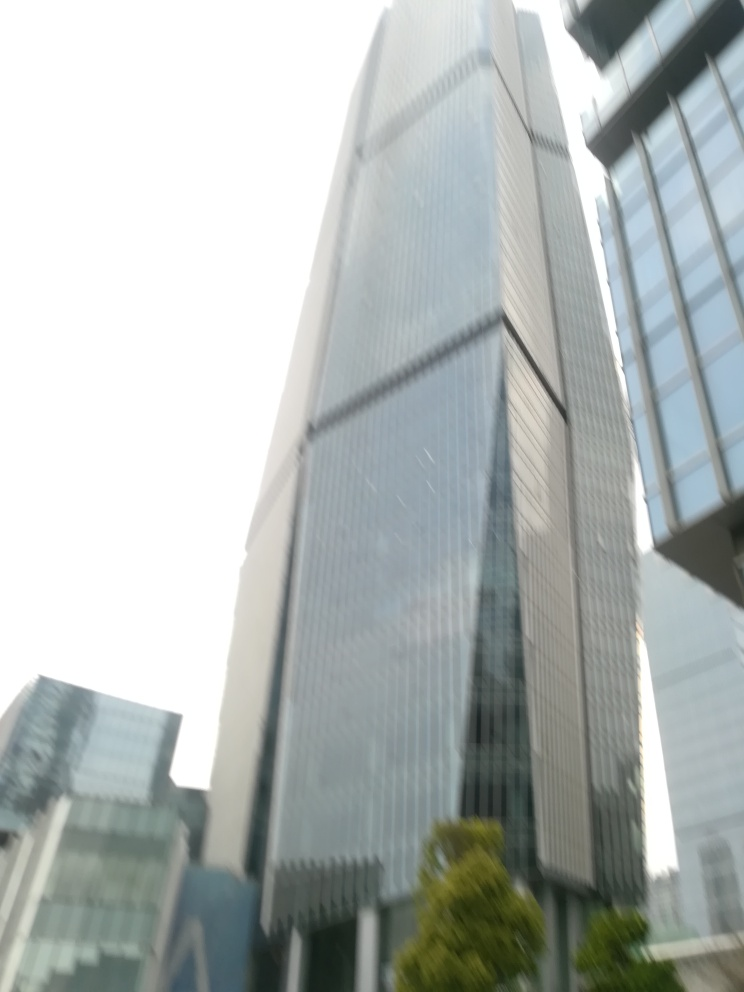Are there any quality issues with this image? Yes, the image appears to be blurry, lacking sharpness and detail, which might be due to motion blur from camera movement or an out-of-focus subject. Additionally, the overexposed sky suggests incorrect exposure settings were used. 